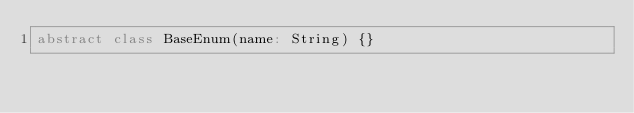Convert code to text. <code><loc_0><loc_0><loc_500><loc_500><_Scala_>abstract class BaseEnum(name: String) {}
</code> 